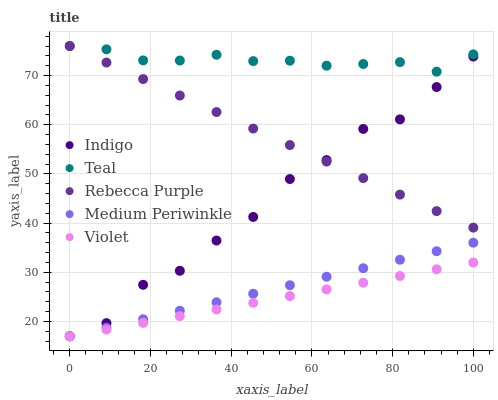Does Violet have the minimum area under the curve?
Answer yes or no. Yes. Does Teal have the maximum area under the curve?
Answer yes or no. Yes. Does Indigo have the minimum area under the curve?
Answer yes or no. No. Does Indigo have the maximum area under the curve?
Answer yes or no. No. Is Medium Periwinkle the smoothest?
Answer yes or no. Yes. Is Indigo the roughest?
Answer yes or no. Yes. Is Rebecca Purple the smoothest?
Answer yes or no. No. Is Rebecca Purple the roughest?
Answer yes or no. No. Does Medium Periwinkle have the lowest value?
Answer yes or no. Yes. Does Rebecca Purple have the lowest value?
Answer yes or no. No. Does Teal have the highest value?
Answer yes or no. Yes. Does Indigo have the highest value?
Answer yes or no. No. Is Violet less than Rebecca Purple?
Answer yes or no. Yes. Is Rebecca Purple greater than Violet?
Answer yes or no. Yes. Does Rebecca Purple intersect Teal?
Answer yes or no. Yes. Is Rebecca Purple less than Teal?
Answer yes or no. No. Is Rebecca Purple greater than Teal?
Answer yes or no. No. Does Violet intersect Rebecca Purple?
Answer yes or no. No. 